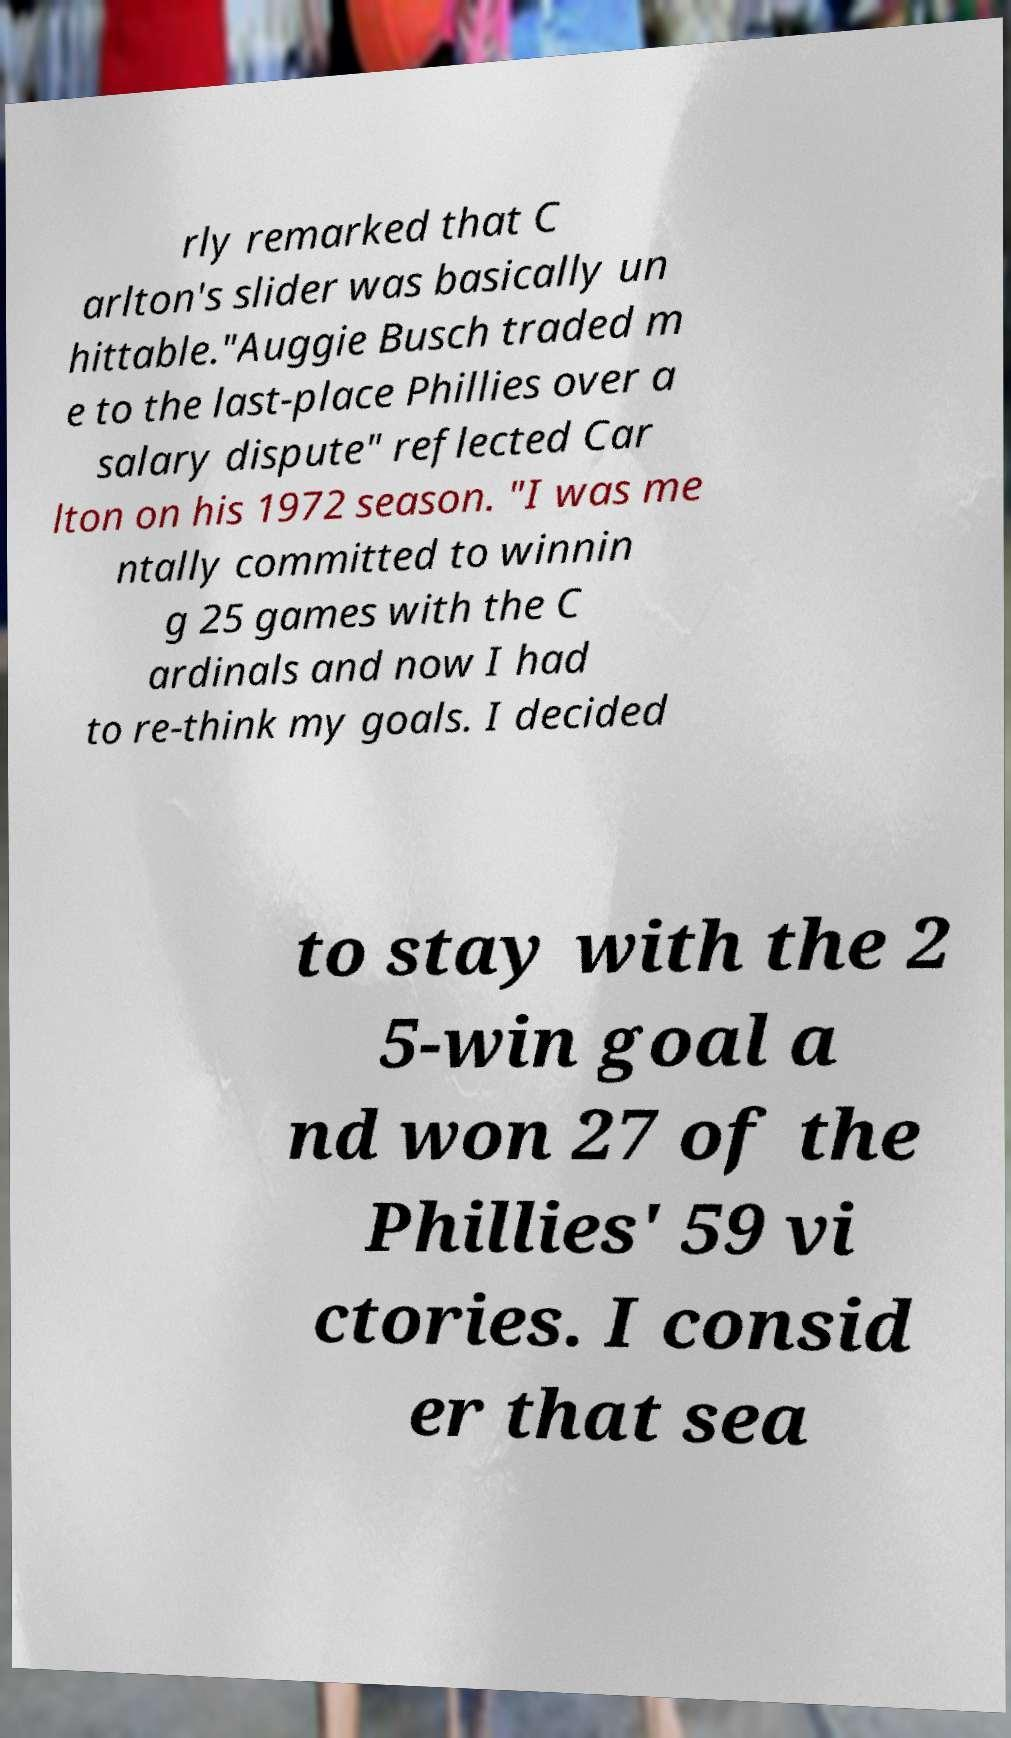Please identify and transcribe the text found in this image. rly remarked that C arlton's slider was basically un hittable."Auggie Busch traded m e to the last-place Phillies over a salary dispute" reflected Car lton on his 1972 season. "I was me ntally committed to winnin g 25 games with the C ardinals and now I had to re-think my goals. I decided to stay with the 2 5-win goal a nd won 27 of the Phillies' 59 vi ctories. I consid er that sea 